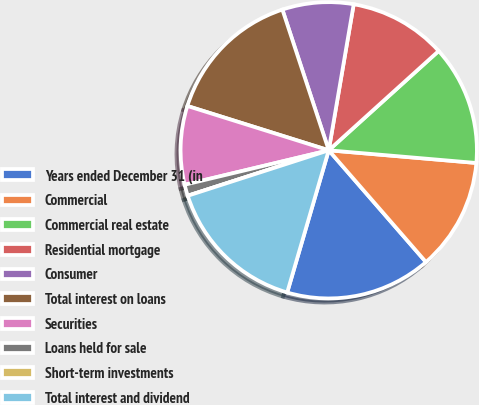<chart> <loc_0><loc_0><loc_500><loc_500><pie_chart><fcel>Years ended December 31 (in<fcel>Commercial<fcel>Commercial real estate<fcel>Residential mortgage<fcel>Consumer<fcel>Total interest on loans<fcel>Securities<fcel>Loans held for sale<fcel>Short-term investments<fcel>Total interest and dividend<nl><fcel>15.92%<fcel>12.24%<fcel>13.06%<fcel>10.61%<fcel>7.76%<fcel>15.1%<fcel>8.57%<fcel>1.23%<fcel>0.0%<fcel>15.51%<nl></chart> 